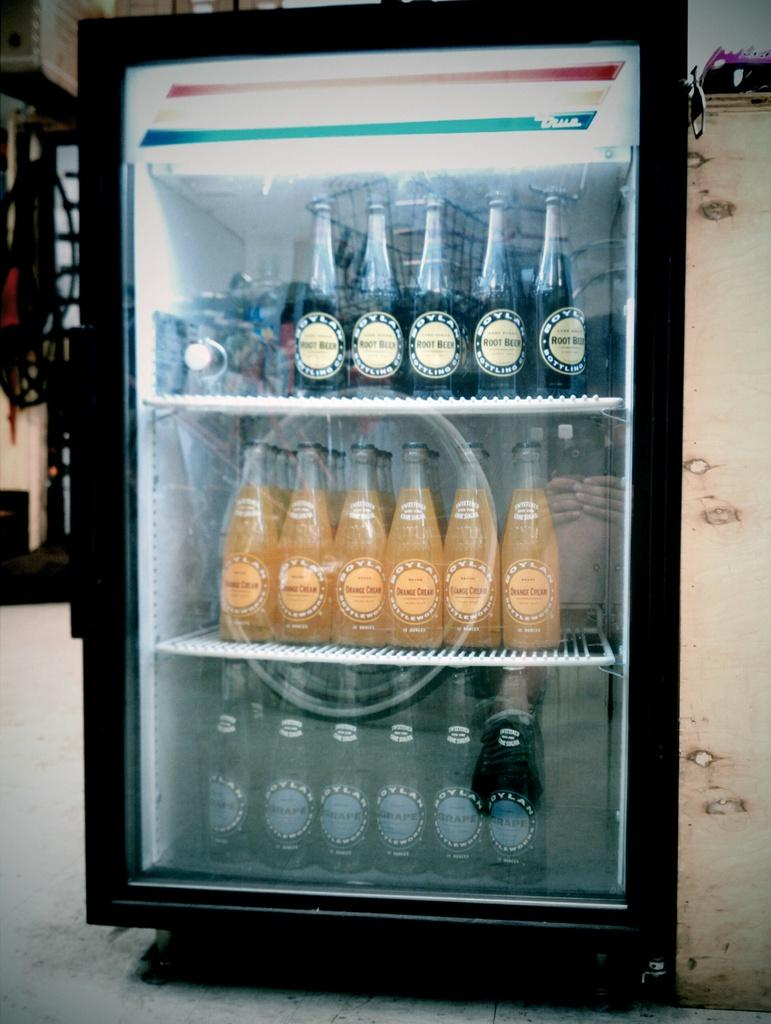What type of appliance is visible in the image? There is a mini refrigerator in the image. What can be found inside the mini refrigerator? Bottles with labels are placed inside the refrigerator. Can you describe the background of the image? The background of the image is blurred. How many kittens are playing in the shoe in the image? There are no kittens or shoes present in the image. 